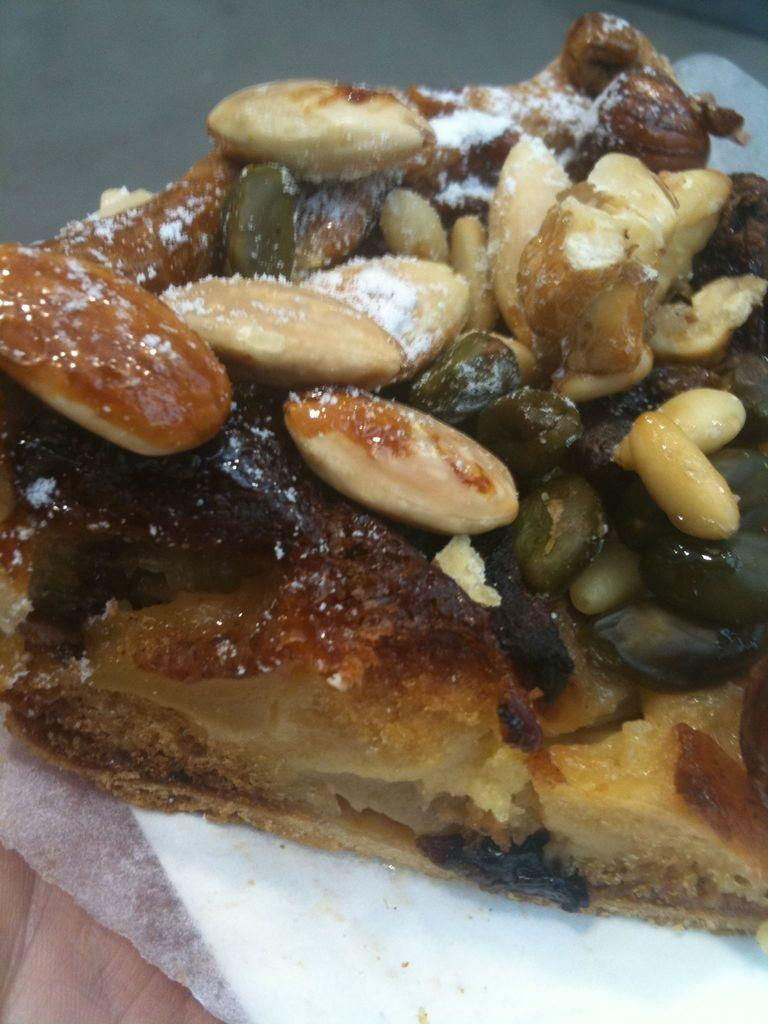What is the main subject in the image? There is a food item in the image. How many spiders are crawling on the food item in the image? There is no mention of spiders in the image, and therefore no such activity can be observed. 